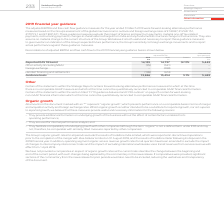From Vodafone Group Plc's financial document, What financial items does guidance basis comprise of? The document contains multiple relevant values: Reported (IAS 18 basis), Other activity (including M&A), Foreign exchange, Handset financing and settlements. From the document: "ding M&A) (95) (341) – Foreign exchange – (288) – Handset financing and settlements (198) (674) – Guidance basis 13,846 13,434 3.1% 5,443 5,443 Other ..." Also, Which financial years' information is shown in the table? The document shows two values: 2018 and 2019. From the document: "2019 €m 2018 €m Growth 2019 €m Reported (IAS 18 basis) 14,139 14,737 (4.1)% 5,443 Other activity (includ 2019 €m 2018 €m Growth 2019 €m Reported (IAS ..." Also, What does the table show? Reconciliations of adjusted EBITDA and free cash flow to the 2019 financial year guidance basis. The document states: "Reconciliations of adjusted EBITDA and free cash flow to the 2019 financial year guidance basis is shown below...." Additionally, Between 2018 and 2019, which year has higher adjusted EBITDA, reported (IAS 18 basis)? According to the financial document, 2018. The relevant text states: "2019 €m 2018 €m Growth 2019 €m Reported (IAS 18 basis) 14,139 14,737 (4.1)% 5,443 Other activity (including M&A)..." Additionally, Between 2018 and 2019, which year had higher adjusted EBITDA, guidance basis? According to the financial document, 2019. The relevant text states: "2019 €m 2018 €m Growth 2019 €m Reported (IAS 18 basis) 14,139 14,737 (4.1)% 5,443 Other activity (includ..." Also, can you calculate: What is the 2019 average adjusted EBITDA, guidance basis? To answer this question, I need to perform calculations using the financial data. The calculation is: (13,846+13,434)/2, which equals 13640 (in millions). This is based on the information: "d settlements (198) (674) – Guidance basis 13,846 13,434 3.1% 5,443 cing and settlements (198) (674) – Guidance basis 13,846 13,434 3.1% 5,443..." The key data points involved are: 13,434, 13,846. 